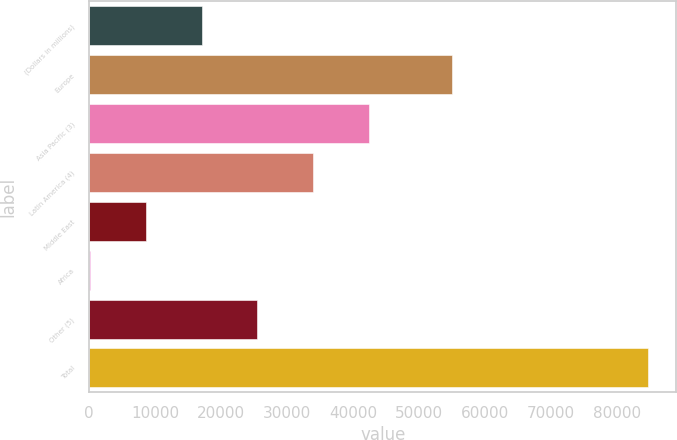<chart> <loc_0><loc_0><loc_500><loc_500><bar_chart><fcel>(Dollars in millions)<fcel>Europe<fcel>Asia Pacific (3)<fcel>Latin America (4)<fcel>Middle East<fcel>Africa<fcel>Other (5)<fcel>Total<nl><fcel>17030.6<fcel>55068<fcel>42447.5<fcel>33975.2<fcel>8558.3<fcel>86<fcel>25502.9<fcel>84809<nl></chart> 